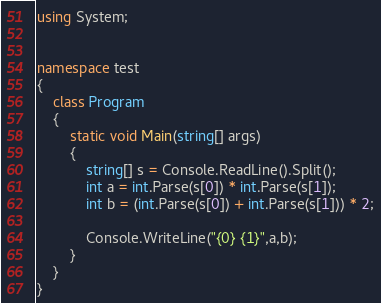Convert code to text. <code><loc_0><loc_0><loc_500><loc_500><_C#_>using System;


namespace test
{
    class Program
    {
        static void Main(string[] args)
        {
            string[] s = Console.ReadLine().Split();
            int a = int.Parse(s[0]) * int.Parse(s[1]);
            int b = (int.Parse(s[0]) + int.Parse(s[1])) * 2;

            Console.WriteLine("{0} {1}",a,b);
        }
    }
}</code> 